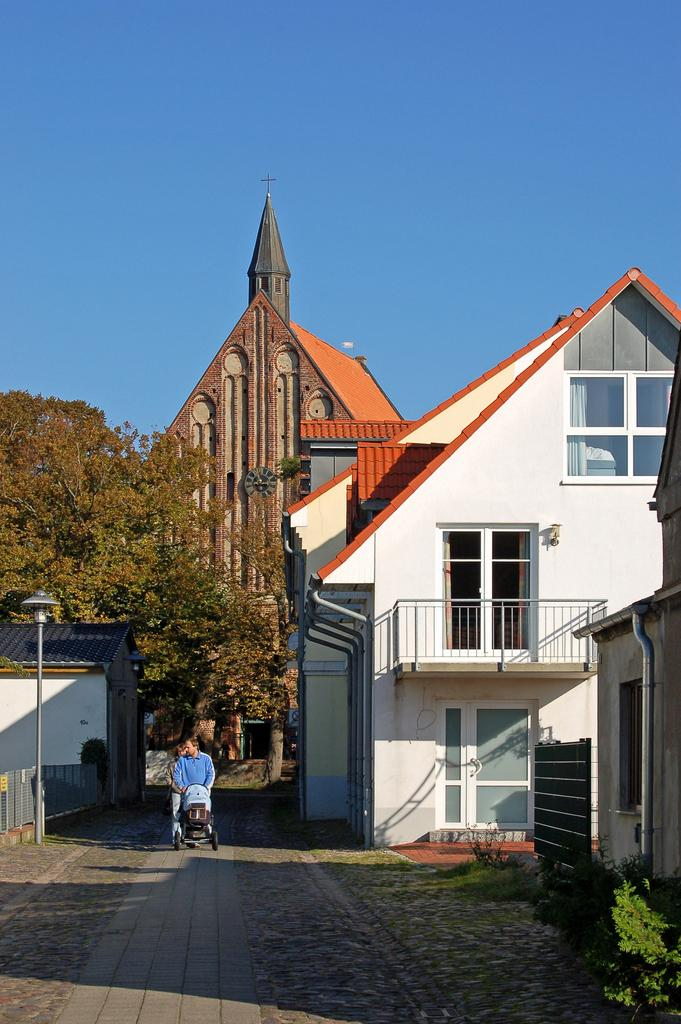What type of structures can be seen in the image? There are houses in the image. What type of vegetation is present in the image? There are trees and plants in the image. Are there any living beings visible in the image? Yes, there are people visible in the image. What type of mask is the cat wearing in the image? There is no cat or mask present in the image. How many balls are visible in the image? There are no balls visible in the image. 